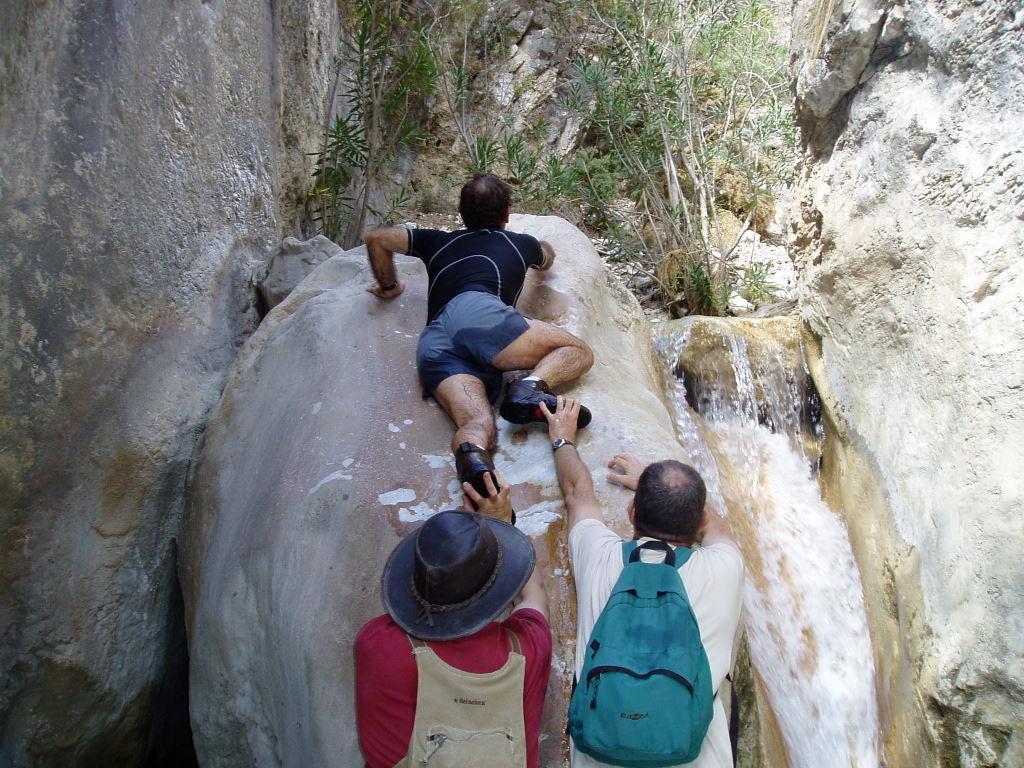How would you summarize this image in a sentence or two? In this image we can see these two persons wearing backpacks and this person wearing hat are standing here. This person is climbing the rock. Here we can see the water, trees and the rocks on the either sides. 